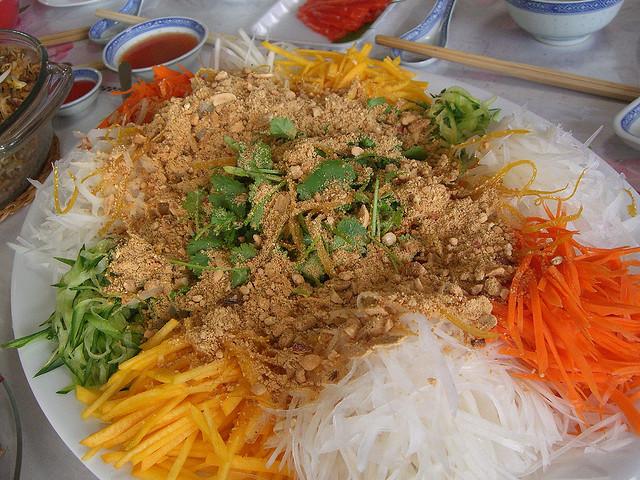Are the carrots cooked?
Be succinct. No. Is this Chinese food?
Be succinct. Yes. What color are the carrots?
Answer briefly. Orange. Is this a colorful mixture of consumable items?
Be succinct. Yes. 